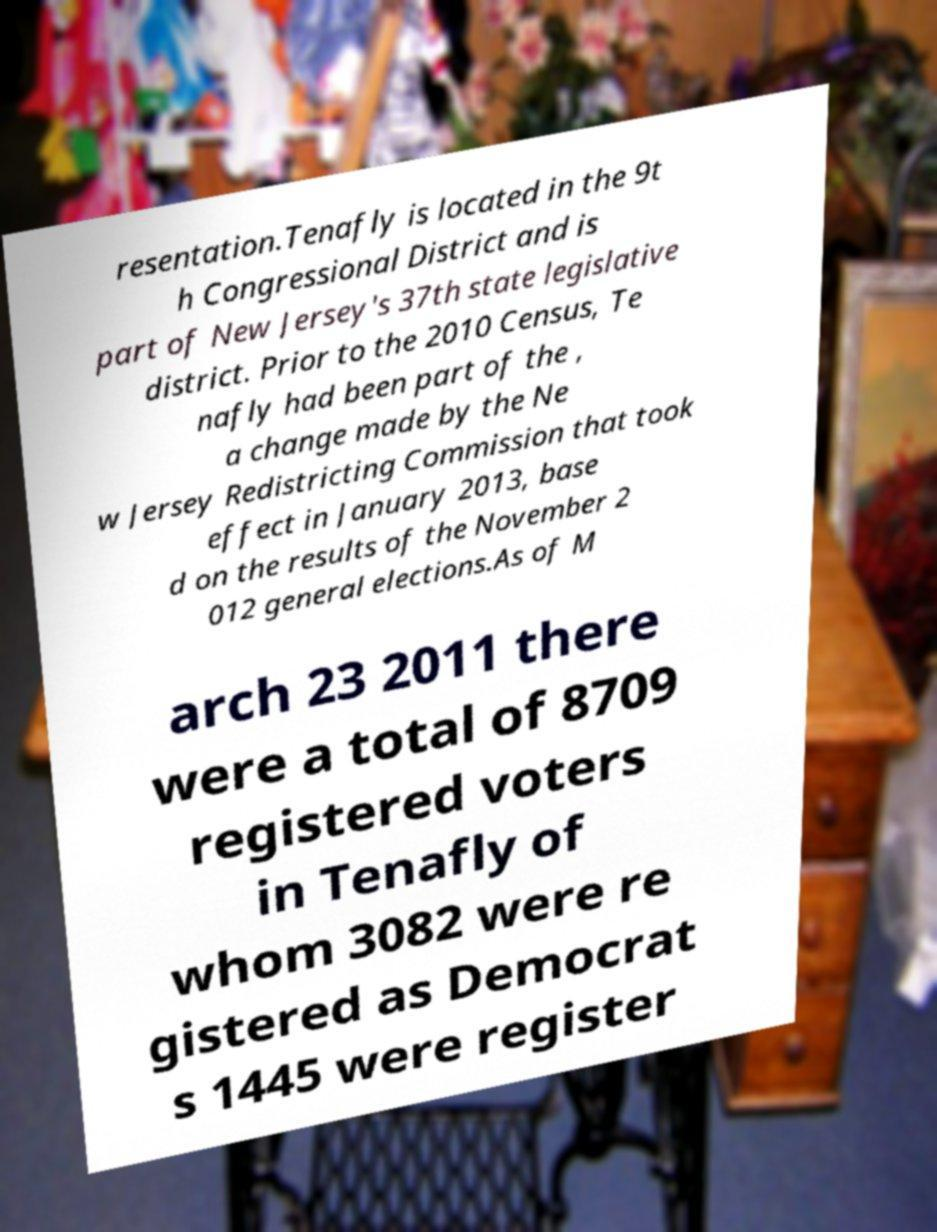For documentation purposes, I need the text within this image transcribed. Could you provide that? resentation.Tenafly is located in the 9t h Congressional District and is part of New Jersey's 37th state legislative district. Prior to the 2010 Census, Te nafly had been part of the , a change made by the Ne w Jersey Redistricting Commission that took effect in January 2013, base d on the results of the November 2 012 general elections.As of M arch 23 2011 there were a total of 8709 registered voters in Tenafly of whom 3082 were re gistered as Democrat s 1445 were register 